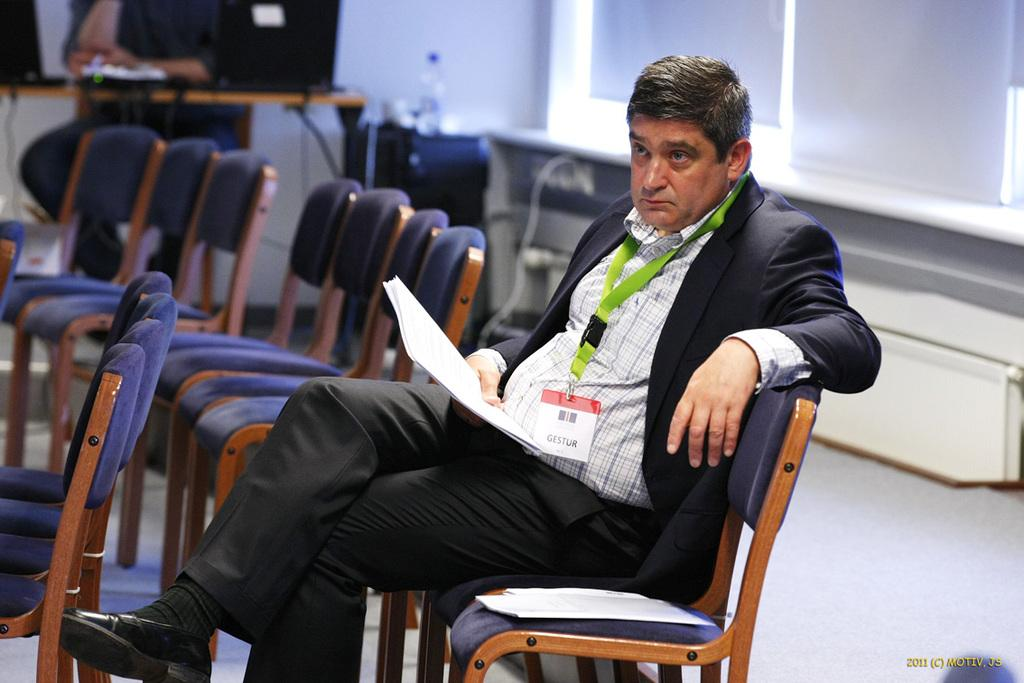What is the man in the foreground of the image doing? The man in the foreground of the image is seated on a chair and holding a piece of paper. Can you describe the activity of the man in the background of the image? The man in the background of the image is working with a laptop. What object is visible in the image besides the chairs and people? There is a bottle visible in the image. How many rabbits can be seen nesting in the patch of grass in the image? There are no rabbits or patches of grass present in the image. 